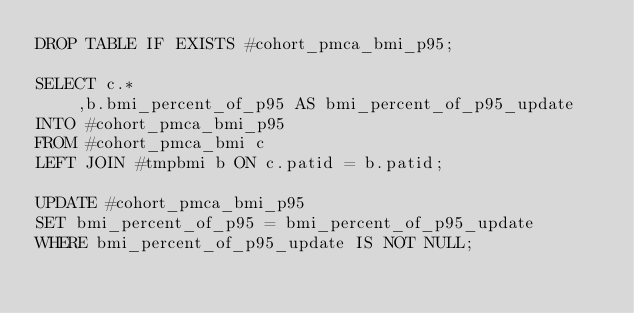Convert code to text. <code><loc_0><loc_0><loc_500><loc_500><_SQL_>DROP TABLE IF EXISTS #cohort_pmca_bmi_p95;

SELECT c.*
	,b.bmi_percent_of_p95 AS bmi_percent_of_p95_update
INTO #cohort_pmca_bmi_p95
FROM #cohort_pmca_bmi c
LEFT JOIN #tmpbmi b ON c.patid = b.patid;

UPDATE #cohort_pmca_bmi_p95
SET bmi_percent_of_p95 = bmi_percent_of_p95_update
WHERE bmi_percent_of_p95_update IS NOT NULL;

</code> 